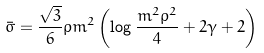Convert formula to latex. <formula><loc_0><loc_0><loc_500><loc_500>\bar { \sigma } = \frac { \sqrt { 3 } } { 6 } \rho m ^ { 2 } \left ( \log \frac { m ^ { 2 } \rho ^ { 2 } } { 4 } + 2 \gamma + 2 \right )</formula> 